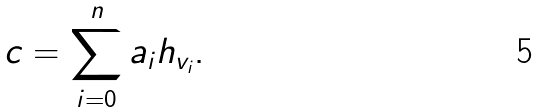<formula> <loc_0><loc_0><loc_500><loc_500>c = \sum _ { i = 0 } ^ { n } a _ { i } h _ { v _ { i } } .</formula> 